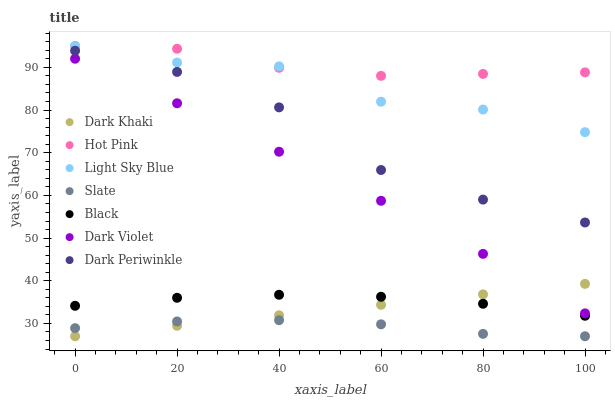Does Slate have the minimum area under the curve?
Answer yes or no. Yes. Does Hot Pink have the maximum area under the curve?
Answer yes or no. Yes. Does Dark Violet have the minimum area under the curve?
Answer yes or no. No. Does Dark Violet have the maximum area under the curve?
Answer yes or no. No. Is Dark Khaki the smoothest?
Answer yes or no. Yes. Is Light Sky Blue the roughest?
Answer yes or no. Yes. Is Hot Pink the smoothest?
Answer yes or no. No. Is Hot Pink the roughest?
Answer yes or no. No. Does Slate have the lowest value?
Answer yes or no. Yes. Does Dark Violet have the lowest value?
Answer yes or no. No. Does Light Sky Blue have the highest value?
Answer yes or no. Yes. Does Dark Violet have the highest value?
Answer yes or no. No. Is Slate less than Hot Pink?
Answer yes or no. Yes. Is Dark Violet greater than Black?
Answer yes or no. Yes. Does Slate intersect Dark Khaki?
Answer yes or no. Yes. Is Slate less than Dark Khaki?
Answer yes or no. No. Is Slate greater than Dark Khaki?
Answer yes or no. No. Does Slate intersect Hot Pink?
Answer yes or no. No. 